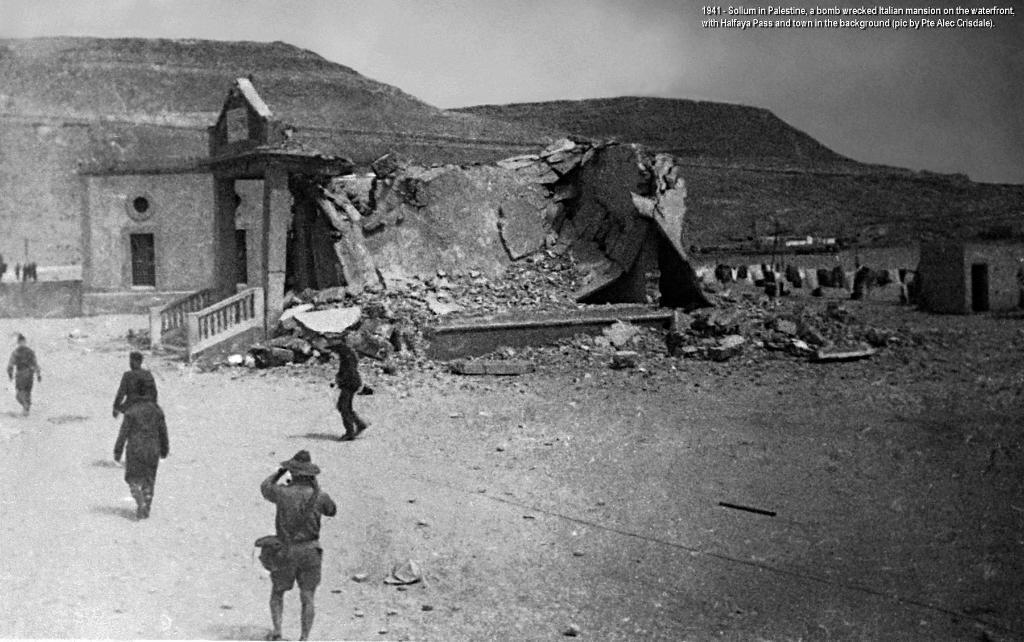Can you describe this image briefly? It looks like a black and white picture. We can see a group of people walking on the path and in front of the people it is looking like a house, hills and sky. On the image there is a watermark. 